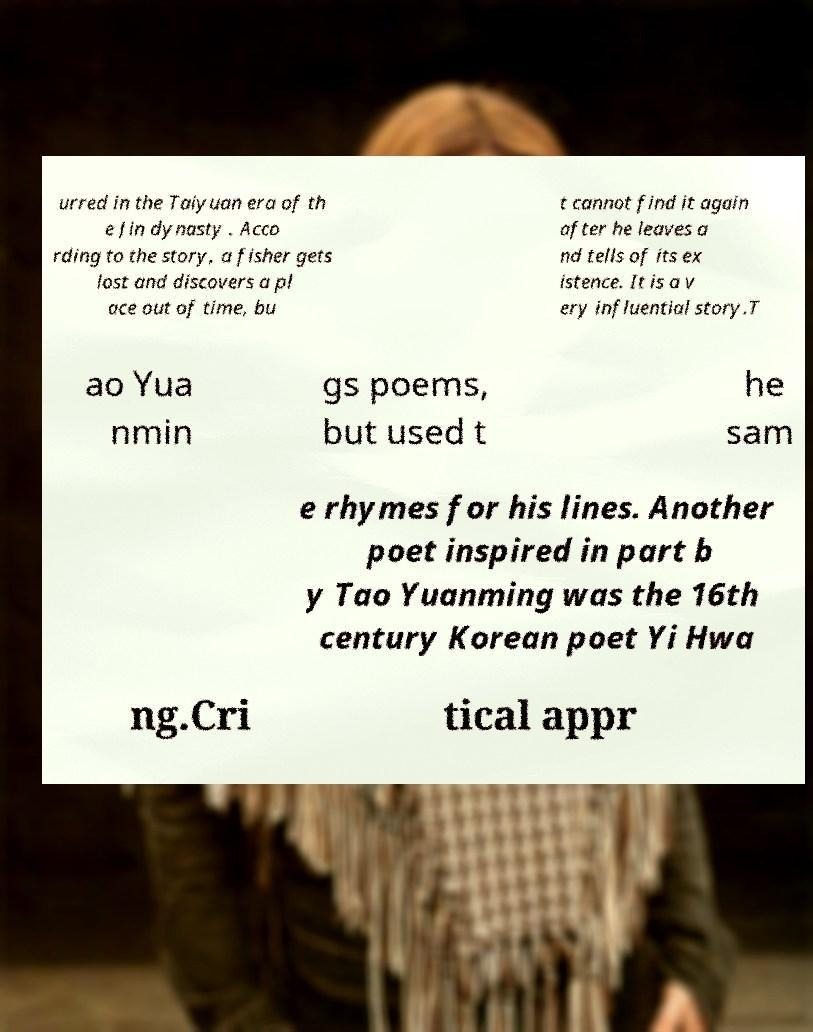Can you read and provide the text displayed in the image?This photo seems to have some interesting text. Can you extract and type it out for me? urred in the Taiyuan era of th e Jin dynasty . Acco rding to the story, a fisher gets lost and discovers a pl ace out of time, bu t cannot find it again after he leaves a nd tells of its ex istence. It is a v ery influential story.T ao Yua nmin gs poems, but used t he sam e rhymes for his lines. Another poet inspired in part b y Tao Yuanming was the 16th century Korean poet Yi Hwa ng.Cri tical appr 